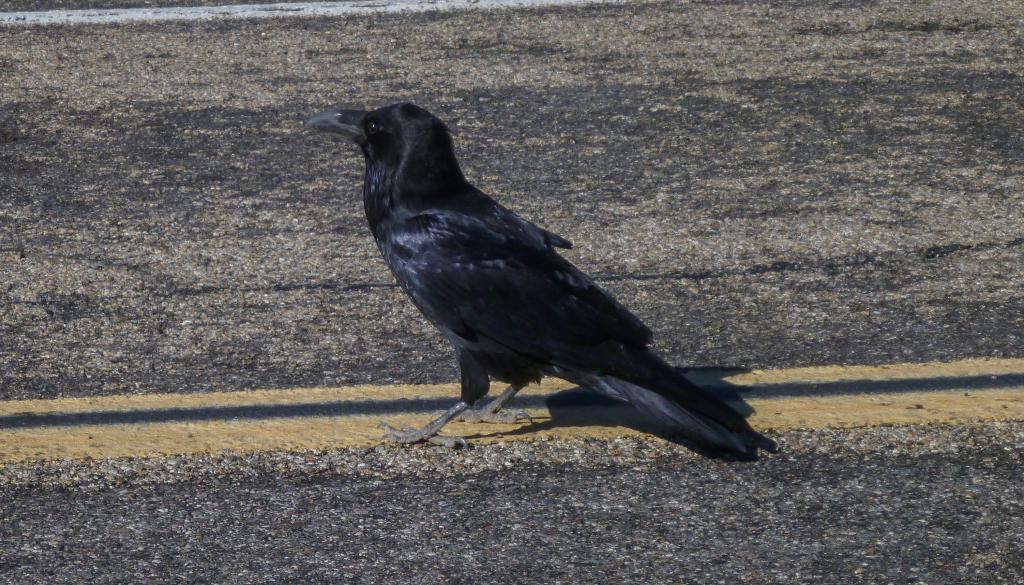How would you summarize this image in a sentence or two? There is a crow standing on the road. On the road there is a yellow line. 